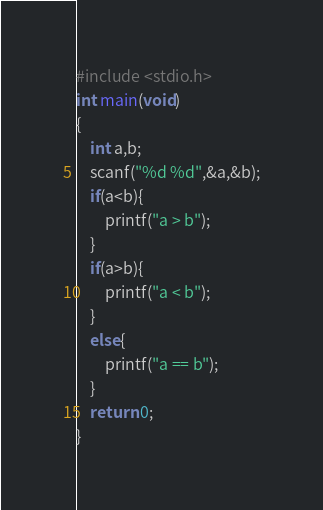<code> <loc_0><loc_0><loc_500><loc_500><_C_>#include <stdio.h>
int main(void)
{
    int a,b;
    scanf("%d %d",&a,&b);
    if(a<b){
        printf("a > b");
    }
    if(a>b){
        printf("a < b");
    }
    else{
        printf("a == b");
    }
    return 0;
}

</code> 